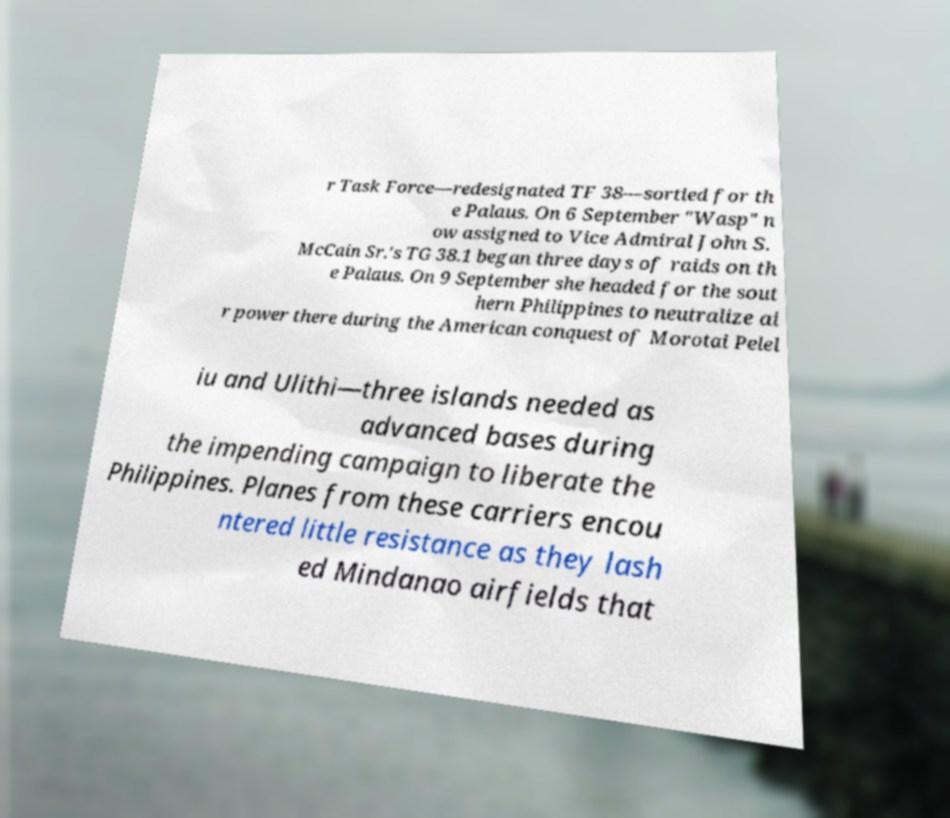There's text embedded in this image that I need extracted. Can you transcribe it verbatim? r Task Force—redesignated TF 38—sortied for th e Palaus. On 6 September "Wasp" n ow assigned to Vice Admiral John S. McCain Sr.'s TG 38.1 began three days of raids on th e Palaus. On 9 September she headed for the sout hern Philippines to neutralize ai r power there during the American conquest of Morotai Pelel iu and Ulithi—three islands needed as advanced bases during the impending campaign to liberate the Philippines. Planes from these carriers encou ntered little resistance as they lash ed Mindanao airfields that 